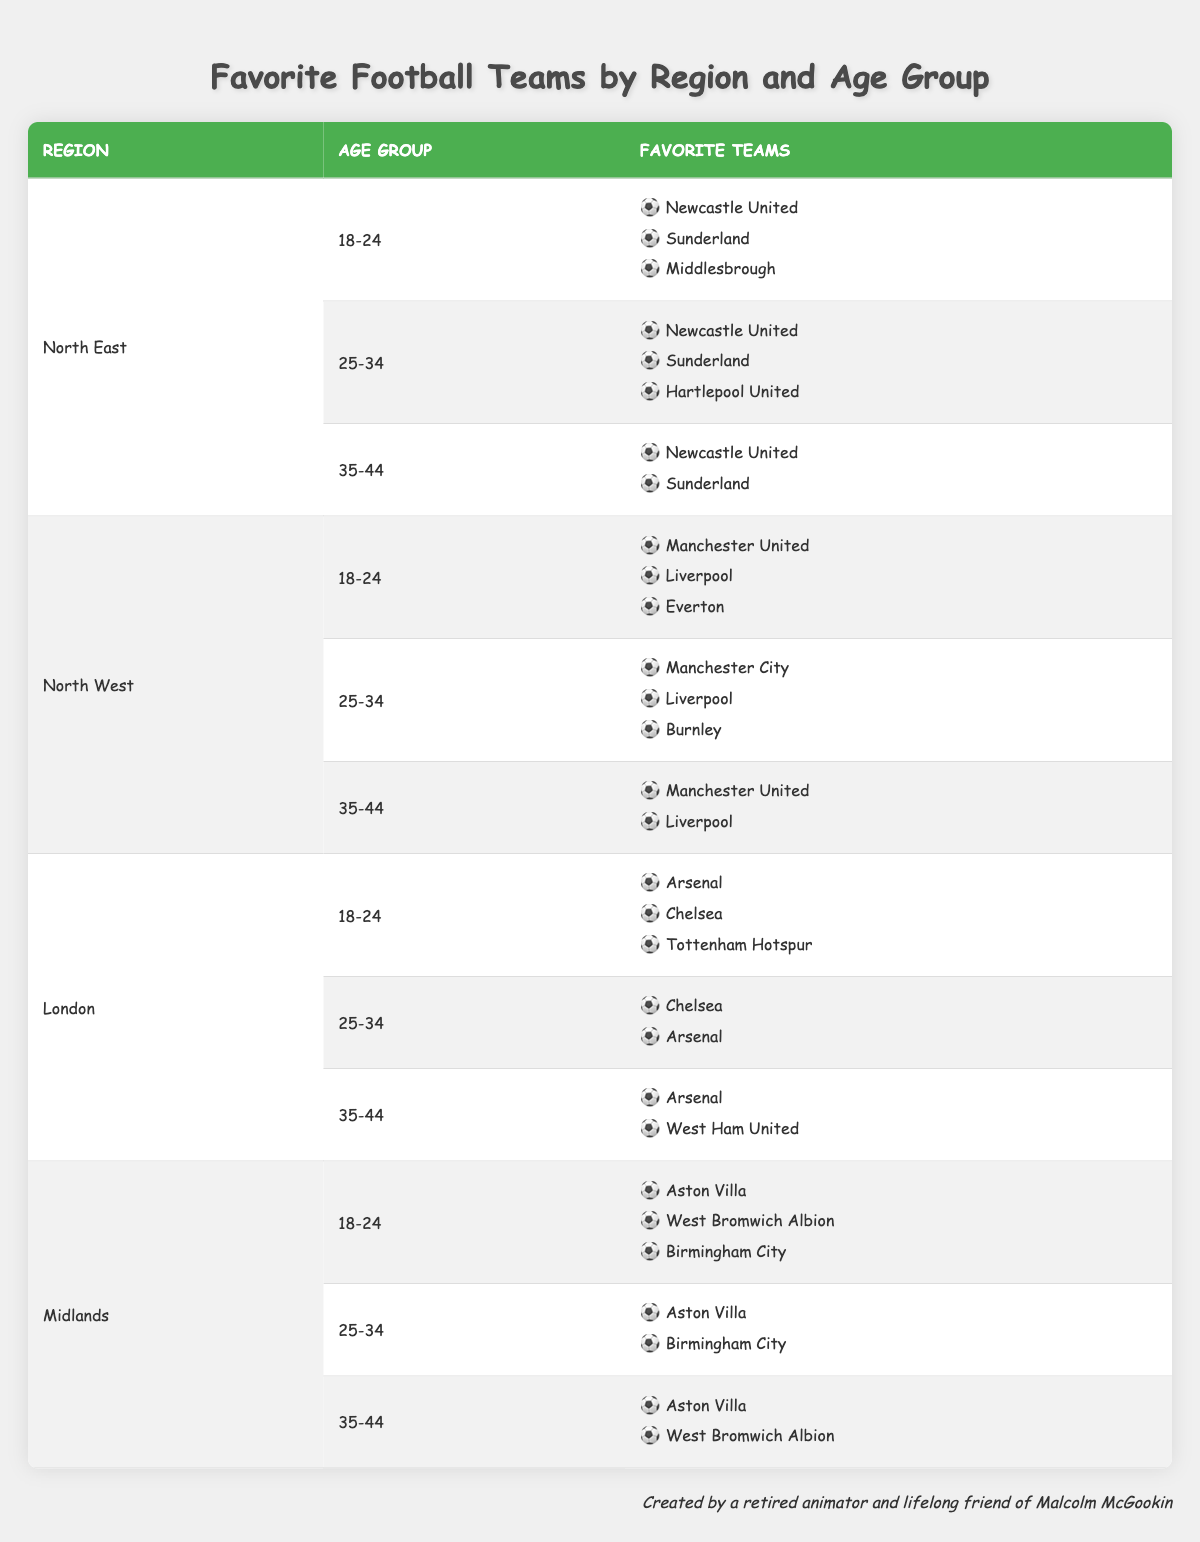What are the favorite teams for the 18-24 age group in the North East region? The table indicates that in the North East, for the age group 18-24, the favorite teams are Newcastle United, Sunderland, and Middlesbrough. This information can be found in the first row of the North East's data.
Answer: Newcastle United, Sunderland, Middlesbrough Which region has the most favorite teams listed for the 35-44 age group? By reviewing the rows for the 35-44 age group in each region, the North East and North West both show 2 teams (Newcastle United, Sunderland) and (Manchester United, Liverpool), while London and Midlands both have 2 teams listed as well. Hence, all regions have the same number of teams for this age group.
Answer: All regions have the same number Is "Aston Villa" a favorite team for any age group in the Midlands? From the table, Aston Villa appears as a favorite team in the 18-24, 25-34, and 35-44 age groups for the Midlands region. Each relevant row shows Aston Villa listed among the favorite teams. Therefore, the statement is true.
Answer: Yes How many total unique favorite teams are listed for the North West region across all age groups? The North West region has three age groups, listing the following unique teams: Manchester United, Liverpool, Everton, Manchester City, and Burnley. Reviewing all rows, we find a total of 5 unique teams listed for the North West.
Answer: 5 Which age group in the London region has the fewest favorite teams? In the London region, the age group 25-34 lists 2 favorite teams (Chelsea and Arsenal), which is fewer than the 18-24 age group's 3 teams (Arsenal, Chelsea, Tottenham Hotspur) and the 35-44 age group's 2 teams (Arsenal, West Ham United). Thus, the 25-34 and 35-44 age groups tie for the fewest teams.
Answer: 25-34 and 35-44 In the North East, how does the number of favorite teams for the 25-34 age group compare to the 35-44 age group? For the North East, the 25-34 age group has 3 favorite teams listed (Newcastle United, Sunderland, Hartlepool United) while the 35-44 age group has 2 teams (Newcastle United, Sunderland). Therefore, the 25-34 age group has 1 more favorite team than the 35-44 age group.
Answer: 1 more team Is "Liverpool" a favorite team for the 25-34 age group in the North West region? The table shows that for the 25-34 age group in the North West, the favorite teams are Manchester City, Liverpool, and Burnley. Therefore, the statement that Liverpool is a favorite team for this age group is true.
Answer: Yes Which favorite teams appear in both the 18-24 and 35-44 age groups for the North West? Looking at the North West region, the 18-24 age group includes Manchester United, Liverpool, and Everton, while the 35-44 age group features Manchester United and Liverpool. The common teams between the two age groups are Manchester United and Liverpool.
Answer: Manchester United, Liverpool 